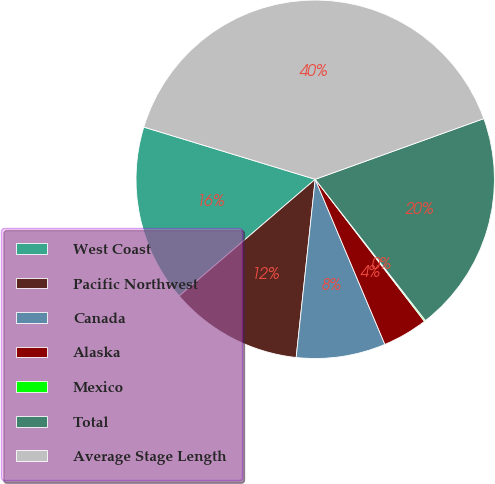Convert chart. <chart><loc_0><loc_0><loc_500><loc_500><pie_chart><fcel>West Coast<fcel>Pacific Northwest<fcel>Canada<fcel>Alaska<fcel>Mexico<fcel>Total<fcel>Average Stage Length<nl><fcel>15.99%<fcel>12.02%<fcel>8.05%<fcel>4.08%<fcel>0.11%<fcel>19.95%<fcel>39.79%<nl></chart> 